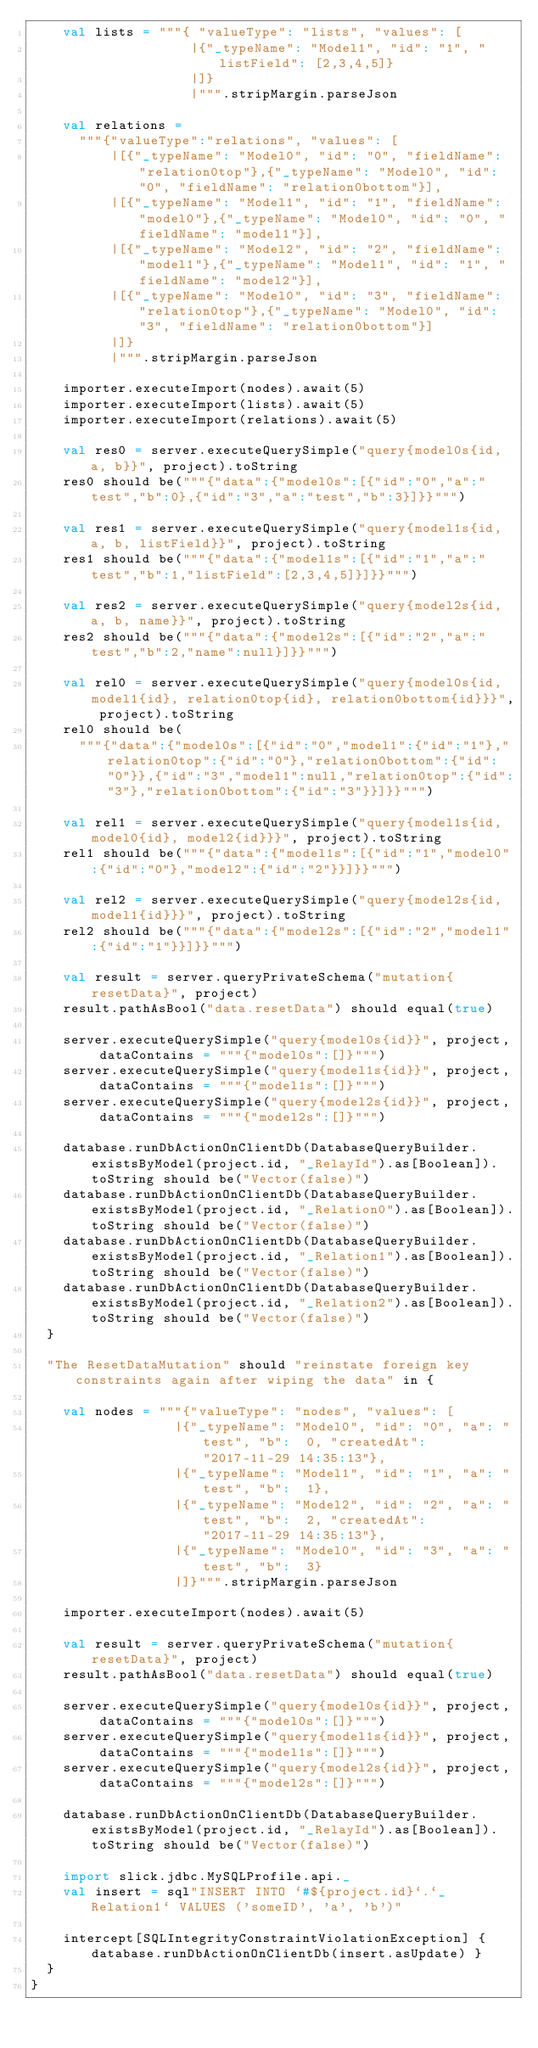Convert code to text. <code><loc_0><loc_0><loc_500><loc_500><_Scala_>    val lists = """{ "valueType": "lists", "values": [
                    |{"_typeName": "Model1", "id": "1", "listField": [2,3,4,5]}
                    |]}
                    |""".stripMargin.parseJson

    val relations =
      """{"valueType":"relations", "values": [
          |[{"_typeName": "Model0", "id": "0", "fieldName": "relation0top"},{"_typeName": "Model0", "id": "0", "fieldName": "relation0bottom"}],
          |[{"_typeName": "Model1", "id": "1", "fieldName": "model0"},{"_typeName": "Model0", "id": "0", "fieldName": "model1"}],
          |[{"_typeName": "Model2", "id": "2", "fieldName": "model1"},{"_typeName": "Model1", "id": "1", "fieldName": "model2"}],
          |[{"_typeName": "Model0", "id": "3", "fieldName": "relation0top"},{"_typeName": "Model0", "id": "3", "fieldName": "relation0bottom"}]
          |]}
          |""".stripMargin.parseJson

    importer.executeImport(nodes).await(5)
    importer.executeImport(lists).await(5)
    importer.executeImport(relations).await(5)

    val res0 = server.executeQuerySimple("query{model0s{id, a, b}}", project).toString
    res0 should be("""{"data":{"model0s":[{"id":"0","a":"test","b":0},{"id":"3","a":"test","b":3}]}}""")

    val res1 = server.executeQuerySimple("query{model1s{id, a, b, listField}}", project).toString
    res1 should be("""{"data":{"model1s":[{"id":"1","a":"test","b":1,"listField":[2,3,4,5]}]}}""")

    val res2 = server.executeQuerySimple("query{model2s{id, a, b, name}}", project).toString
    res2 should be("""{"data":{"model2s":[{"id":"2","a":"test","b":2,"name":null}]}}""")

    val rel0 = server.executeQuerySimple("query{model0s{id, model1{id}, relation0top{id}, relation0bottom{id}}}", project).toString
    rel0 should be(
      """{"data":{"model0s":[{"id":"0","model1":{"id":"1"},"relation0top":{"id":"0"},"relation0bottom":{"id":"0"}},{"id":"3","model1":null,"relation0top":{"id":"3"},"relation0bottom":{"id":"3"}}]}}""")

    val rel1 = server.executeQuerySimple("query{model1s{id, model0{id}, model2{id}}}", project).toString
    rel1 should be("""{"data":{"model1s":[{"id":"1","model0":{"id":"0"},"model2":{"id":"2"}}]}}""")

    val rel2 = server.executeQuerySimple("query{model2s{id, model1{id}}}", project).toString
    rel2 should be("""{"data":{"model2s":[{"id":"2","model1":{"id":"1"}}]}}""")

    val result = server.queryPrivateSchema("mutation{resetData}", project)
    result.pathAsBool("data.resetData") should equal(true)

    server.executeQuerySimple("query{model0s{id}}", project, dataContains = """{"model0s":[]}""")
    server.executeQuerySimple("query{model1s{id}}", project, dataContains = """{"model1s":[]}""")
    server.executeQuerySimple("query{model2s{id}}", project, dataContains = """{"model2s":[]}""")

    database.runDbActionOnClientDb(DatabaseQueryBuilder.existsByModel(project.id, "_RelayId").as[Boolean]).toString should be("Vector(false)")
    database.runDbActionOnClientDb(DatabaseQueryBuilder.existsByModel(project.id, "_Relation0").as[Boolean]).toString should be("Vector(false)")
    database.runDbActionOnClientDb(DatabaseQueryBuilder.existsByModel(project.id, "_Relation1").as[Boolean]).toString should be("Vector(false)")
    database.runDbActionOnClientDb(DatabaseQueryBuilder.existsByModel(project.id, "_Relation2").as[Boolean]).toString should be("Vector(false)")
  }

  "The ResetDataMutation" should "reinstate foreign key constraints again after wiping the data" in {

    val nodes = """{"valueType": "nodes", "values": [
                  |{"_typeName": "Model0", "id": "0", "a": "test", "b":  0, "createdAt": "2017-11-29 14:35:13"},
                  |{"_typeName": "Model1", "id": "1", "a": "test", "b":  1},
                  |{"_typeName": "Model2", "id": "2", "a": "test", "b":  2, "createdAt": "2017-11-29 14:35:13"},
                  |{"_typeName": "Model0", "id": "3", "a": "test", "b":  3}
                  |]}""".stripMargin.parseJson

    importer.executeImport(nodes).await(5)

    val result = server.queryPrivateSchema("mutation{resetData}", project)
    result.pathAsBool("data.resetData") should equal(true)

    server.executeQuerySimple("query{model0s{id}}", project, dataContains = """{"model0s":[]}""")
    server.executeQuerySimple("query{model1s{id}}", project, dataContains = """{"model1s":[]}""")
    server.executeQuerySimple("query{model2s{id}}", project, dataContains = """{"model2s":[]}""")

    database.runDbActionOnClientDb(DatabaseQueryBuilder.existsByModel(project.id, "_RelayId").as[Boolean]).toString should be("Vector(false)")

    import slick.jdbc.MySQLProfile.api._
    val insert = sql"INSERT INTO `#${project.id}`.`_Relation1` VALUES ('someID', 'a', 'b')"

    intercept[SQLIntegrityConstraintViolationException] { database.runDbActionOnClientDb(insert.asUpdate) }
  }
}
</code> 